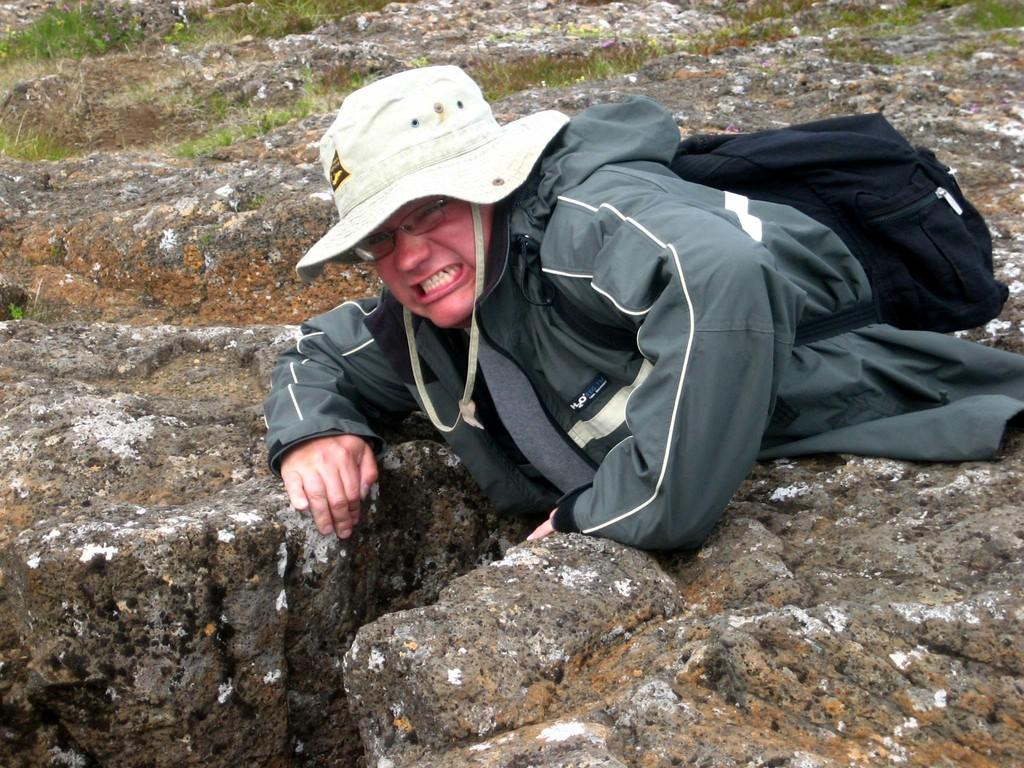Who is the main subject in the image? There is a man in the center of the image. What is the man wearing on his head? The man is wearing a white hat. What object is associated with the man in the image? There is a black bag in the image, and the man is associated with it. What type of ground is visible in the background of the image? There is grass on the ground in the background of the image. What time of day is it in the image, considering the presence of legs? There is no mention of legs in the image, and the time of day cannot be determined based on the provided facts. 